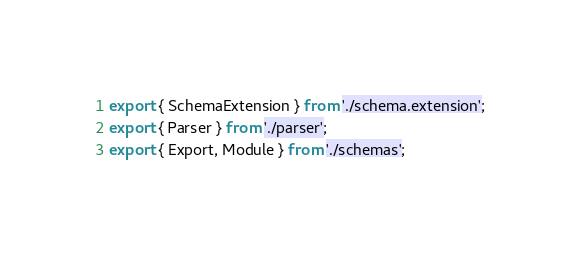Convert code to text. <code><loc_0><loc_0><loc_500><loc_500><_TypeScript_>export { SchemaExtension } from './schema.extension';
export { Parser } from './parser';
export { Export, Module } from './schemas';
</code> 